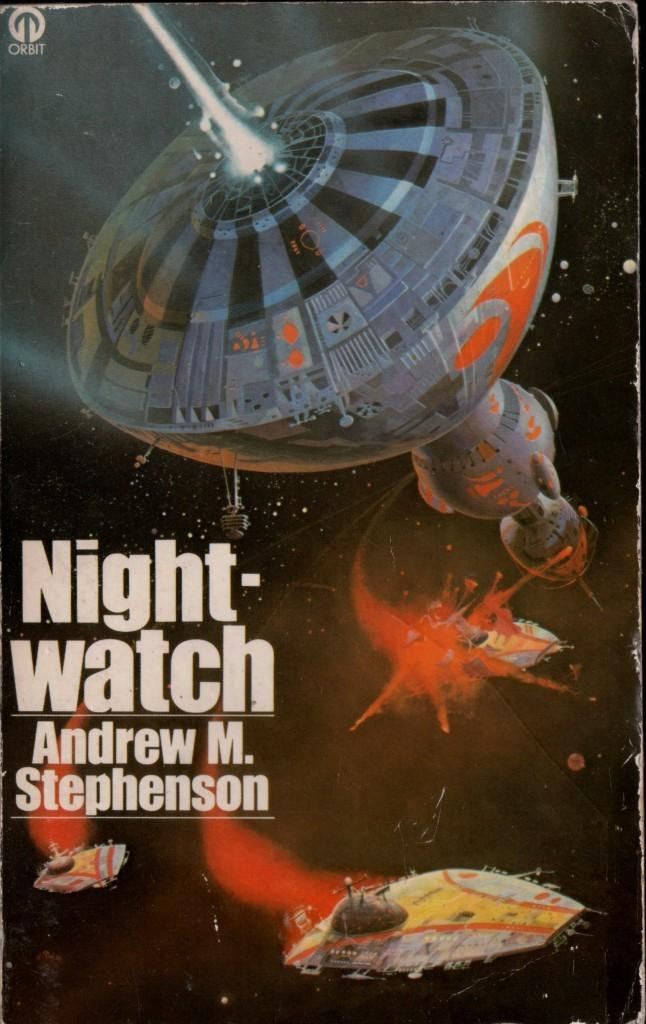<image>
Write a terse but informative summary of the picture. A book titled Night watch by Andrew M. Stephenson 